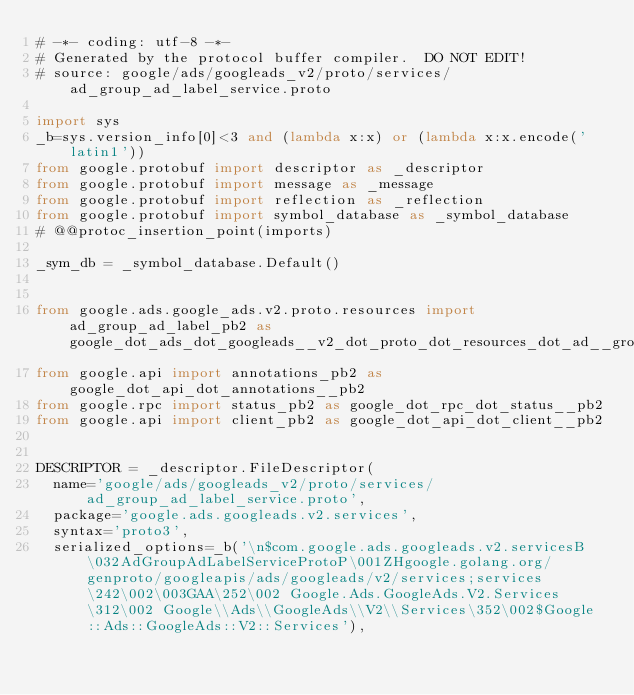<code> <loc_0><loc_0><loc_500><loc_500><_Python_># -*- coding: utf-8 -*-
# Generated by the protocol buffer compiler.  DO NOT EDIT!
# source: google/ads/googleads_v2/proto/services/ad_group_ad_label_service.proto

import sys
_b=sys.version_info[0]<3 and (lambda x:x) or (lambda x:x.encode('latin1'))
from google.protobuf import descriptor as _descriptor
from google.protobuf import message as _message
from google.protobuf import reflection as _reflection
from google.protobuf import symbol_database as _symbol_database
# @@protoc_insertion_point(imports)

_sym_db = _symbol_database.Default()


from google.ads.google_ads.v2.proto.resources import ad_group_ad_label_pb2 as google_dot_ads_dot_googleads__v2_dot_proto_dot_resources_dot_ad__group__ad__label__pb2
from google.api import annotations_pb2 as google_dot_api_dot_annotations__pb2
from google.rpc import status_pb2 as google_dot_rpc_dot_status__pb2
from google.api import client_pb2 as google_dot_api_dot_client__pb2


DESCRIPTOR = _descriptor.FileDescriptor(
  name='google/ads/googleads_v2/proto/services/ad_group_ad_label_service.proto',
  package='google.ads.googleads.v2.services',
  syntax='proto3',
  serialized_options=_b('\n$com.google.ads.googleads.v2.servicesB\032AdGroupAdLabelServiceProtoP\001ZHgoogle.golang.org/genproto/googleapis/ads/googleads/v2/services;services\242\002\003GAA\252\002 Google.Ads.GoogleAds.V2.Services\312\002 Google\\Ads\\GoogleAds\\V2\\Services\352\002$Google::Ads::GoogleAds::V2::Services'),</code> 